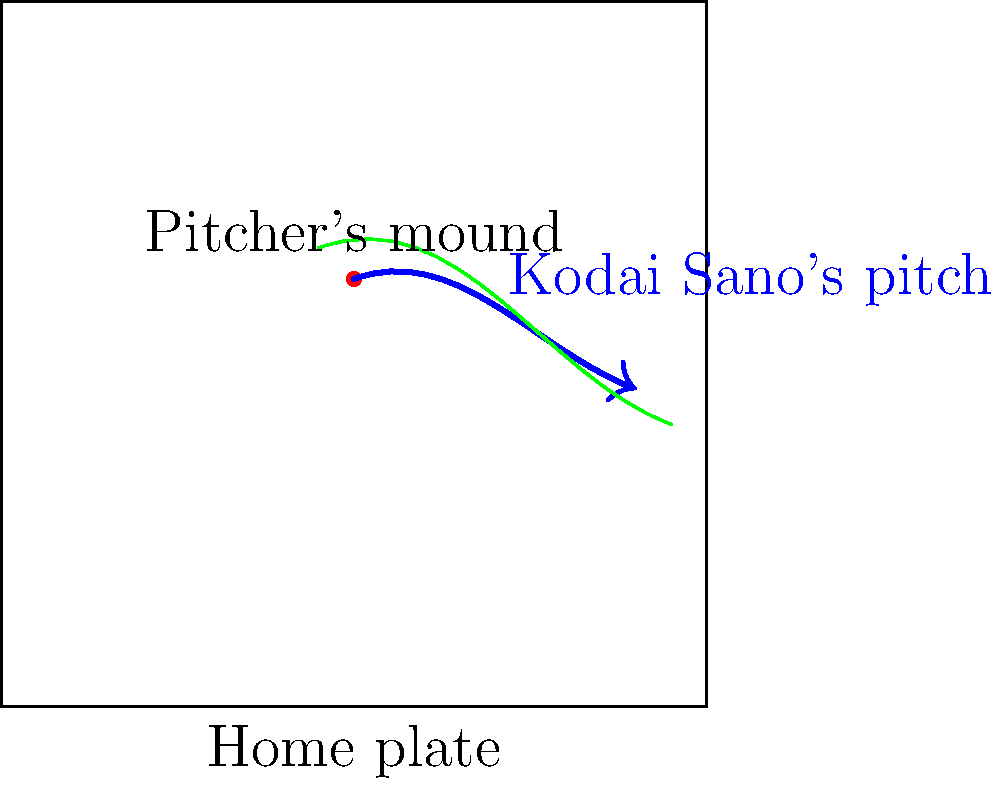Consider the diagram representing a baseball field with Kodai Sano's pitching trajectory. If we create a continuous loop around his pitch trajectory without intersecting it, what topological property does this configuration exhibit, and how does it relate to the concept of homotopy? To answer this question, let's break it down step-by-step:

1. Observe the diagram: We see a baseball field with Kodai Sano's pitching trajectory (blue arrow) and a dashed green loop enclosing it.

2. Understand the topological space: The baseball field can be considered as a subset of the 2D plane, which is our topological space.

3. Examine the loop: The green dashed line forms a closed loop that encloses Sano's pitching trajectory without intersecting it.

4. Recall the concept of homotopy: Two paths in a topological space are homotopic if one can be continuously deformed into the other without leaving the space.

5. Apply homotopy to our scenario: The loop around Sano's pitch can be continuously shrunk without intersecting the trajectory.

6. Identify the key property: This ability to shrink the loop to a point indicates that the loop is null-homotopic.

7. Relate to the pitch: The fact that the loop is null-homotopic implies that Sano's pitch doesn't "puncture" or create a "hole" in the topological space of the field.

8. Conclude: This configuration exhibits the property of simple connectedness, as any loop in the space can be continuously contracted to a point.
Answer: Simple connectedness 